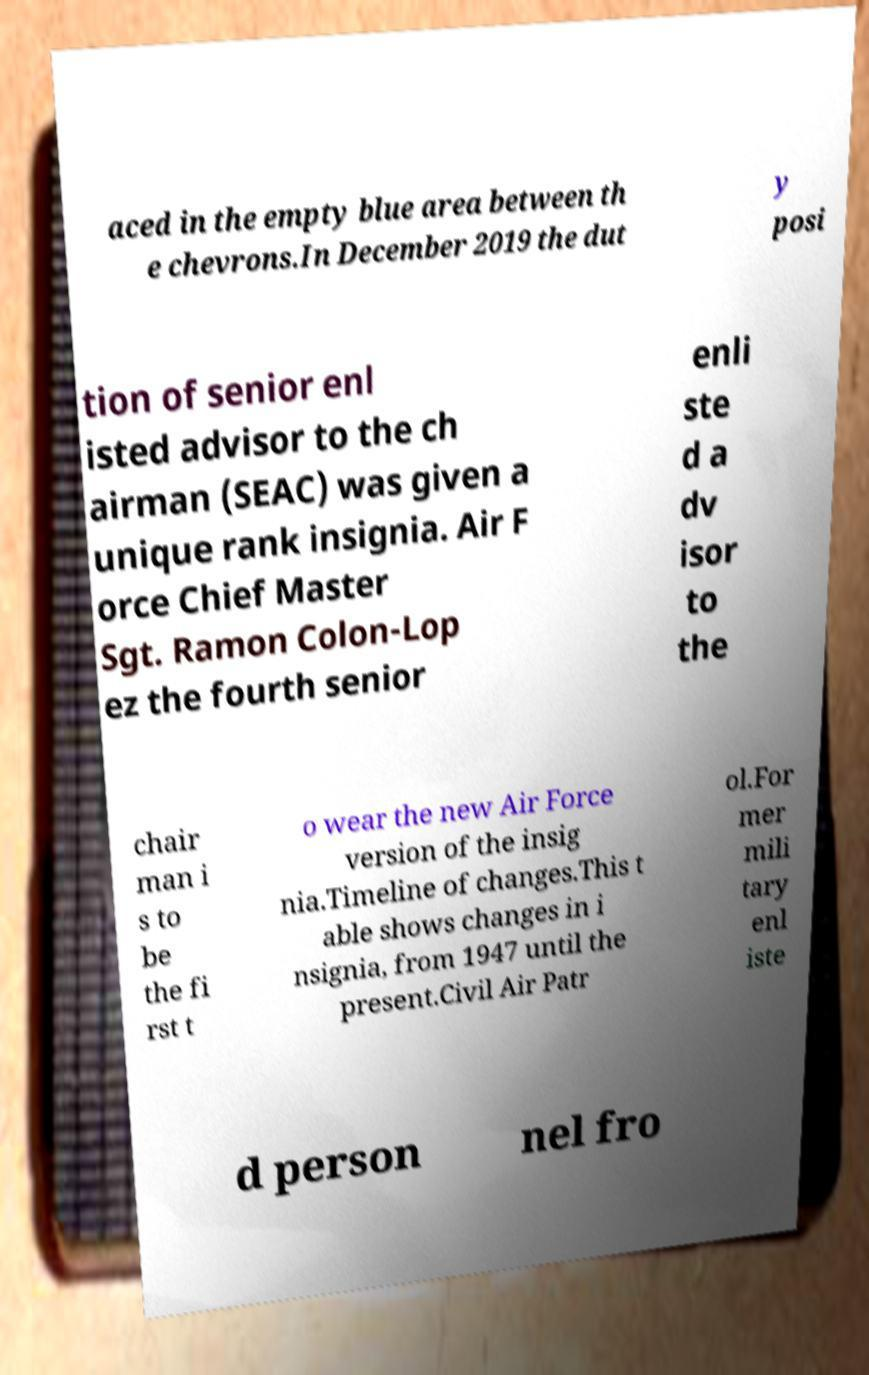Could you extract and type out the text from this image? aced in the empty blue area between th e chevrons.In December 2019 the dut y posi tion of senior enl isted advisor to the ch airman (SEAC) was given a unique rank insignia. Air F orce Chief Master Sgt. Ramon Colon-Lop ez the fourth senior enli ste d a dv isor to the chair man i s to be the fi rst t o wear the new Air Force version of the insig nia.Timeline of changes.This t able shows changes in i nsignia, from 1947 until the present.Civil Air Patr ol.For mer mili tary enl iste d person nel fro 